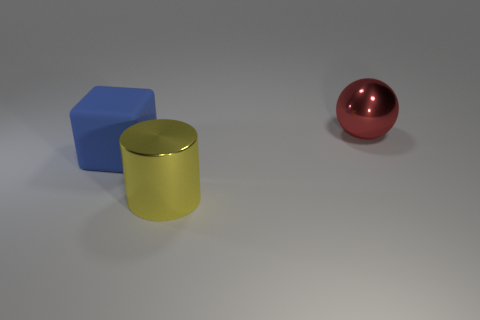Does the large metal object that is in front of the blue cube have the same shape as the big blue object?
Your answer should be compact. No. Is there any other thing that is the same size as the yellow metal cylinder?
Your answer should be very brief. Yes. Is the number of big yellow things that are to the left of the large blue matte thing less than the number of blocks that are right of the big yellow metal cylinder?
Make the answer very short. No. What number of other objects are the same shape as the red shiny thing?
Offer a very short reply. 0. How big is the object to the left of the big yellow thing that is to the right of the big blue cube that is behind the large yellow thing?
Your answer should be very brief. Large. How many green objects are tiny metallic blocks or big objects?
Keep it short and to the point. 0. What is the shape of the big shiny thing that is to the right of the metal thing that is in front of the sphere?
Ensure brevity in your answer.  Sphere. There is a metallic object that is in front of the big blue matte thing; is it the same size as the object right of the big yellow shiny cylinder?
Provide a short and direct response. Yes. Is there a yellow cylinder made of the same material as the block?
Ensure brevity in your answer.  No. There is a thing right of the shiny object in front of the matte object; is there a big yellow shiny object that is right of it?
Your answer should be very brief. No. 